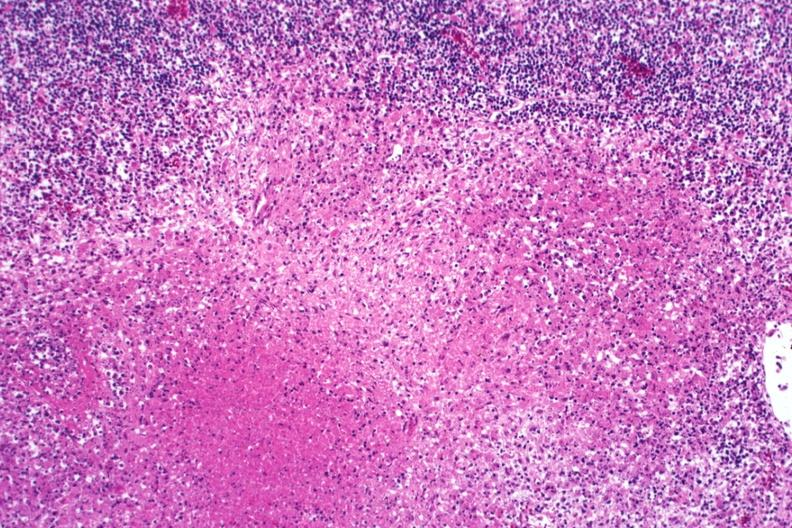does this image show typical necrotizing granulomas?
Answer the question using a single word or phrase. Yes 